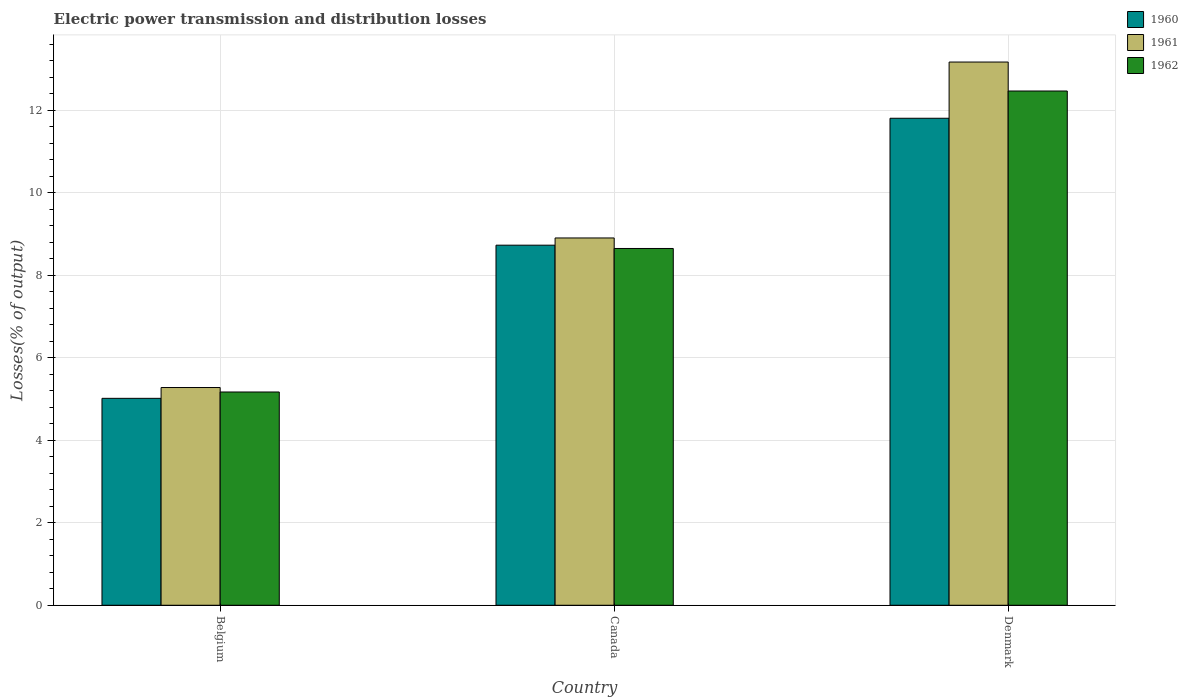How many different coloured bars are there?
Give a very brief answer. 3. Are the number of bars on each tick of the X-axis equal?
Provide a short and direct response. Yes. How many bars are there on the 1st tick from the left?
Your answer should be compact. 3. In how many cases, is the number of bars for a given country not equal to the number of legend labels?
Give a very brief answer. 0. What is the electric power transmission and distribution losses in 1960 in Canada?
Offer a very short reply. 8.73. Across all countries, what is the maximum electric power transmission and distribution losses in 1962?
Offer a terse response. 12.47. Across all countries, what is the minimum electric power transmission and distribution losses in 1960?
Ensure brevity in your answer.  5.02. In which country was the electric power transmission and distribution losses in 1961 maximum?
Offer a terse response. Denmark. In which country was the electric power transmission and distribution losses in 1962 minimum?
Provide a succinct answer. Belgium. What is the total electric power transmission and distribution losses in 1961 in the graph?
Offer a very short reply. 27.35. What is the difference between the electric power transmission and distribution losses in 1962 in Belgium and that in Denmark?
Ensure brevity in your answer.  -7.3. What is the difference between the electric power transmission and distribution losses in 1962 in Denmark and the electric power transmission and distribution losses in 1960 in Canada?
Provide a short and direct response. 3.74. What is the average electric power transmission and distribution losses in 1960 per country?
Give a very brief answer. 8.52. What is the difference between the electric power transmission and distribution losses of/in 1962 and electric power transmission and distribution losses of/in 1960 in Canada?
Provide a short and direct response. -0.08. What is the ratio of the electric power transmission and distribution losses in 1960 in Belgium to that in Canada?
Your answer should be compact. 0.57. Is the electric power transmission and distribution losses in 1960 in Belgium less than that in Canada?
Provide a succinct answer. Yes. Is the difference between the electric power transmission and distribution losses in 1962 in Belgium and Canada greater than the difference between the electric power transmission and distribution losses in 1960 in Belgium and Canada?
Your answer should be compact. Yes. What is the difference between the highest and the second highest electric power transmission and distribution losses in 1961?
Your answer should be compact. 3.63. What is the difference between the highest and the lowest electric power transmission and distribution losses in 1962?
Your answer should be compact. 7.3. In how many countries, is the electric power transmission and distribution losses in 1961 greater than the average electric power transmission and distribution losses in 1961 taken over all countries?
Ensure brevity in your answer.  1. Is the sum of the electric power transmission and distribution losses in 1962 in Belgium and Canada greater than the maximum electric power transmission and distribution losses in 1961 across all countries?
Make the answer very short. Yes. What does the 3rd bar from the left in Belgium represents?
Offer a terse response. 1962. How many countries are there in the graph?
Your response must be concise. 3. Are the values on the major ticks of Y-axis written in scientific E-notation?
Keep it short and to the point. No. Does the graph contain any zero values?
Make the answer very short. No. Does the graph contain grids?
Your response must be concise. Yes. Where does the legend appear in the graph?
Make the answer very short. Top right. How many legend labels are there?
Your response must be concise. 3. What is the title of the graph?
Your response must be concise. Electric power transmission and distribution losses. What is the label or title of the X-axis?
Offer a terse response. Country. What is the label or title of the Y-axis?
Your response must be concise. Losses(% of output). What is the Losses(% of output) in 1960 in Belgium?
Provide a short and direct response. 5.02. What is the Losses(% of output) in 1961 in Belgium?
Offer a terse response. 5.28. What is the Losses(% of output) in 1962 in Belgium?
Provide a short and direct response. 5.17. What is the Losses(% of output) of 1960 in Canada?
Provide a succinct answer. 8.73. What is the Losses(% of output) in 1961 in Canada?
Your answer should be compact. 8.9. What is the Losses(% of output) of 1962 in Canada?
Offer a terse response. 8.65. What is the Losses(% of output) in 1960 in Denmark?
Ensure brevity in your answer.  11.81. What is the Losses(% of output) in 1961 in Denmark?
Ensure brevity in your answer.  13.17. What is the Losses(% of output) in 1962 in Denmark?
Your answer should be very brief. 12.47. Across all countries, what is the maximum Losses(% of output) of 1960?
Make the answer very short. 11.81. Across all countries, what is the maximum Losses(% of output) of 1961?
Provide a short and direct response. 13.17. Across all countries, what is the maximum Losses(% of output) of 1962?
Offer a very short reply. 12.47. Across all countries, what is the minimum Losses(% of output) of 1960?
Keep it short and to the point. 5.02. Across all countries, what is the minimum Losses(% of output) of 1961?
Offer a terse response. 5.28. Across all countries, what is the minimum Losses(% of output) in 1962?
Your answer should be very brief. 5.17. What is the total Losses(% of output) in 1960 in the graph?
Make the answer very short. 25.55. What is the total Losses(% of output) in 1961 in the graph?
Offer a terse response. 27.35. What is the total Losses(% of output) in 1962 in the graph?
Ensure brevity in your answer.  26.28. What is the difference between the Losses(% of output) in 1960 in Belgium and that in Canada?
Make the answer very short. -3.71. What is the difference between the Losses(% of output) in 1961 in Belgium and that in Canada?
Your answer should be compact. -3.63. What is the difference between the Losses(% of output) of 1962 in Belgium and that in Canada?
Make the answer very short. -3.48. What is the difference between the Losses(% of output) of 1960 in Belgium and that in Denmark?
Keep it short and to the point. -6.79. What is the difference between the Losses(% of output) of 1961 in Belgium and that in Denmark?
Offer a terse response. -7.89. What is the difference between the Losses(% of output) in 1962 in Belgium and that in Denmark?
Give a very brief answer. -7.3. What is the difference between the Losses(% of output) in 1960 in Canada and that in Denmark?
Keep it short and to the point. -3.08. What is the difference between the Losses(% of output) of 1961 in Canada and that in Denmark?
Offer a very short reply. -4.26. What is the difference between the Losses(% of output) of 1962 in Canada and that in Denmark?
Your answer should be very brief. -3.82. What is the difference between the Losses(% of output) in 1960 in Belgium and the Losses(% of output) in 1961 in Canada?
Offer a very short reply. -3.89. What is the difference between the Losses(% of output) of 1960 in Belgium and the Losses(% of output) of 1962 in Canada?
Offer a very short reply. -3.63. What is the difference between the Losses(% of output) of 1961 in Belgium and the Losses(% of output) of 1962 in Canada?
Your answer should be very brief. -3.37. What is the difference between the Losses(% of output) in 1960 in Belgium and the Losses(% of output) in 1961 in Denmark?
Provide a succinct answer. -8.15. What is the difference between the Losses(% of output) in 1960 in Belgium and the Losses(% of output) in 1962 in Denmark?
Offer a terse response. -7.45. What is the difference between the Losses(% of output) of 1961 in Belgium and the Losses(% of output) of 1962 in Denmark?
Your answer should be very brief. -7.19. What is the difference between the Losses(% of output) of 1960 in Canada and the Losses(% of output) of 1961 in Denmark?
Provide a short and direct response. -4.44. What is the difference between the Losses(% of output) in 1960 in Canada and the Losses(% of output) in 1962 in Denmark?
Your response must be concise. -3.74. What is the difference between the Losses(% of output) of 1961 in Canada and the Losses(% of output) of 1962 in Denmark?
Your answer should be compact. -3.56. What is the average Losses(% of output) of 1960 per country?
Provide a succinct answer. 8.52. What is the average Losses(% of output) of 1961 per country?
Your answer should be very brief. 9.12. What is the average Losses(% of output) in 1962 per country?
Make the answer very short. 8.76. What is the difference between the Losses(% of output) of 1960 and Losses(% of output) of 1961 in Belgium?
Ensure brevity in your answer.  -0.26. What is the difference between the Losses(% of output) in 1960 and Losses(% of output) in 1962 in Belgium?
Offer a very short reply. -0.15. What is the difference between the Losses(% of output) of 1961 and Losses(% of output) of 1962 in Belgium?
Offer a terse response. 0.11. What is the difference between the Losses(% of output) in 1960 and Losses(% of output) in 1961 in Canada?
Keep it short and to the point. -0.17. What is the difference between the Losses(% of output) of 1960 and Losses(% of output) of 1962 in Canada?
Provide a short and direct response. 0.08. What is the difference between the Losses(% of output) in 1961 and Losses(% of output) in 1962 in Canada?
Give a very brief answer. 0.25. What is the difference between the Losses(% of output) of 1960 and Losses(% of output) of 1961 in Denmark?
Ensure brevity in your answer.  -1.36. What is the difference between the Losses(% of output) in 1960 and Losses(% of output) in 1962 in Denmark?
Offer a terse response. -0.66. What is the difference between the Losses(% of output) in 1961 and Losses(% of output) in 1962 in Denmark?
Give a very brief answer. 0.7. What is the ratio of the Losses(% of output) in 1960 in Belgium to that in Canada?
Your answer should be very brief. 0.57. What is the ratio of the Losses(% of output) in 1961 in Belgium to that in Canada?
Provide a succinct answer. 0.59. What is the ratio of the Losses(% of output) in 1962 in Belgium to that in Canada?
Give a very brief answer. 0.6. What is the ratio of the Losses(% of output) in 1960 in Belgium to that in Denmark?
Offer a very short reply. 0.42. What is the ratio of the Losses(% of output) of 1961 in Belgium to that in Denmark?
Your response must be concise. 0.4. What is the ratio of the Losses(% of output) in 1962 in Belgium to that in Denmark?
Offer a very short reply. 0.41. What is the ratio of the Losses(% of output) in 1960 in Canada to that in Denmark?
Your response must be concise. 0.74. What is the ratio of the Losses(% of output) in 1961 in Canada to that in Denmark?
Provide a succinct answer. 0.68. What is the ratio of the Losses(% of output) of 1962 in Canada to that in Denmark?
Offer a terse response. 0.69. What is the difference between the highest and the second highest Losses(% of output) of 1960?
Your response must be concise. 3.08. What is the difference between the highest and the second highest Losses(% of output) in 1961?
Make the answer very short. 4.26. What is the difference between the highest and the second highest Losses(% of output) in 1962?
Keep it short and to the point. 3.82. What is the difference between the highest and the lowest Losses(% of output) in 1960?
Provide a succinct answer. 6.79. What is the difference between the highest and the lowest Losses(% of output) in 1961?
Your response must be concise. 7.89. What is the difference between the highest and the lowest Losses(% of output) of 1962?
Provide a short and direct response. 7.3. 